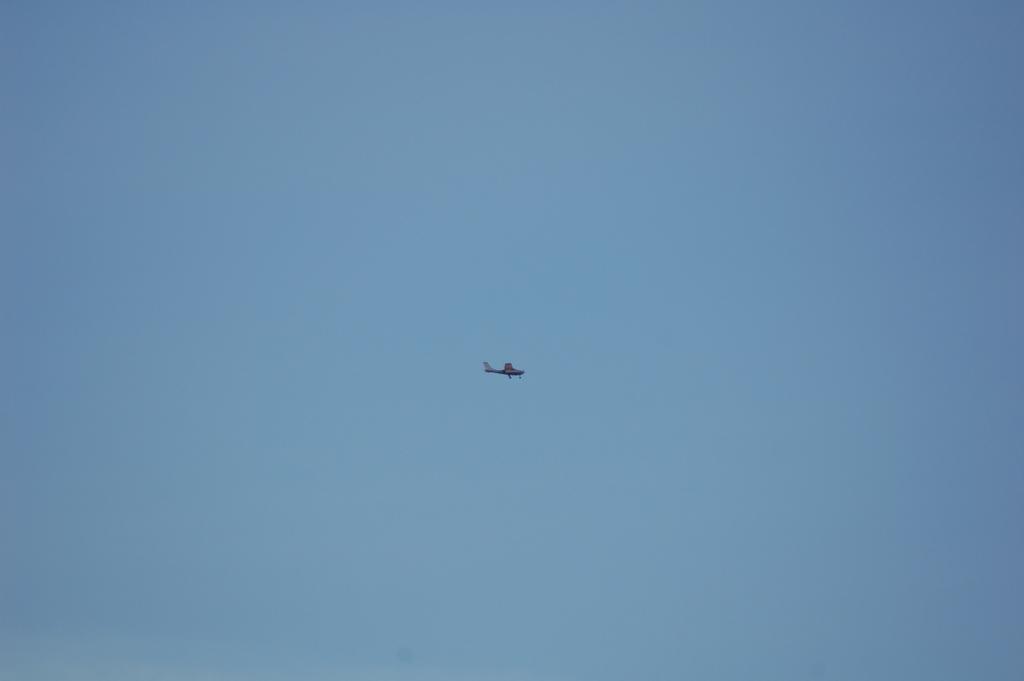Describe this image in one or two sentences. In this image we can see an airplane flying in the sky, there is sky at the top. 